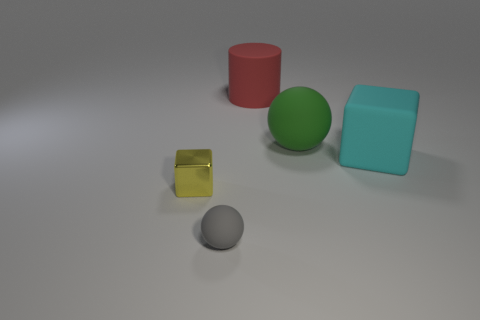What textures are visible on the objects in this scene? The objects exhibit a mix of textures: the large cyan cube and the small yellow object have a matte surface, reducing glare and reflection, while the green sphere and the red cylinder seem to have a slightly reflective surface, giving them a subtle shine. The grey sphere appears to have a rough texture, possibly resembling concrete or stone. 